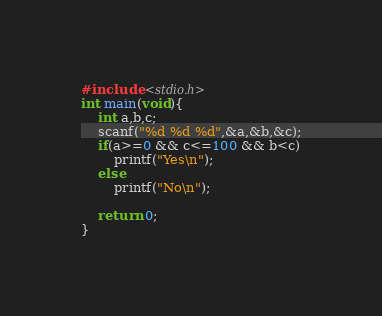<code> <loc_0><loc_0><loc_500><loc_500><_C_>#include <stdio.h>
int main(void){
    int a,b,c;
    scanf("%d %d %d",&a,&b,&c);
    if(a>=0 && c<=100 && b<c)
        printf("Yes\n");
    else
        printf("No\n");
    
    return 0;
}</code> 